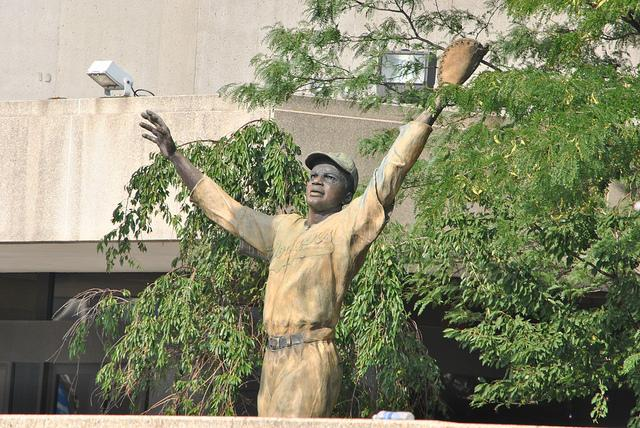What is the statue wearing? Please explain your reasoning. belt. The statue has a belt over the uniform. 